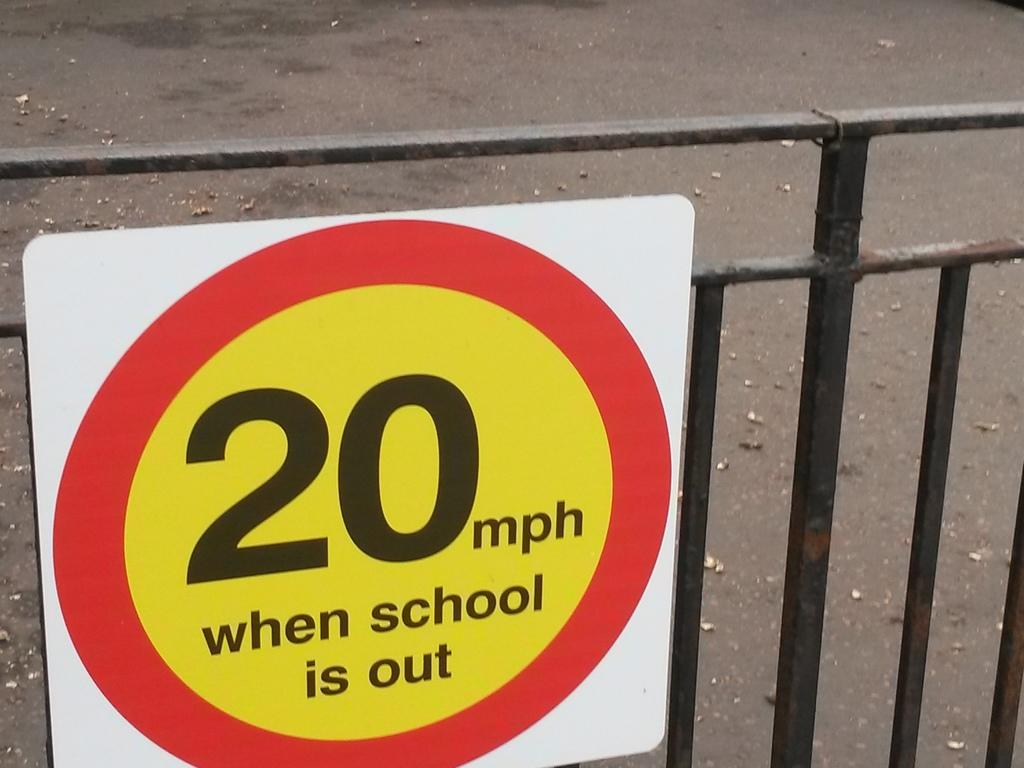<image>
Relay a brief, clear account of the picture shown. A caution sign for drivers to change their speed to 20 mph when school is out. 